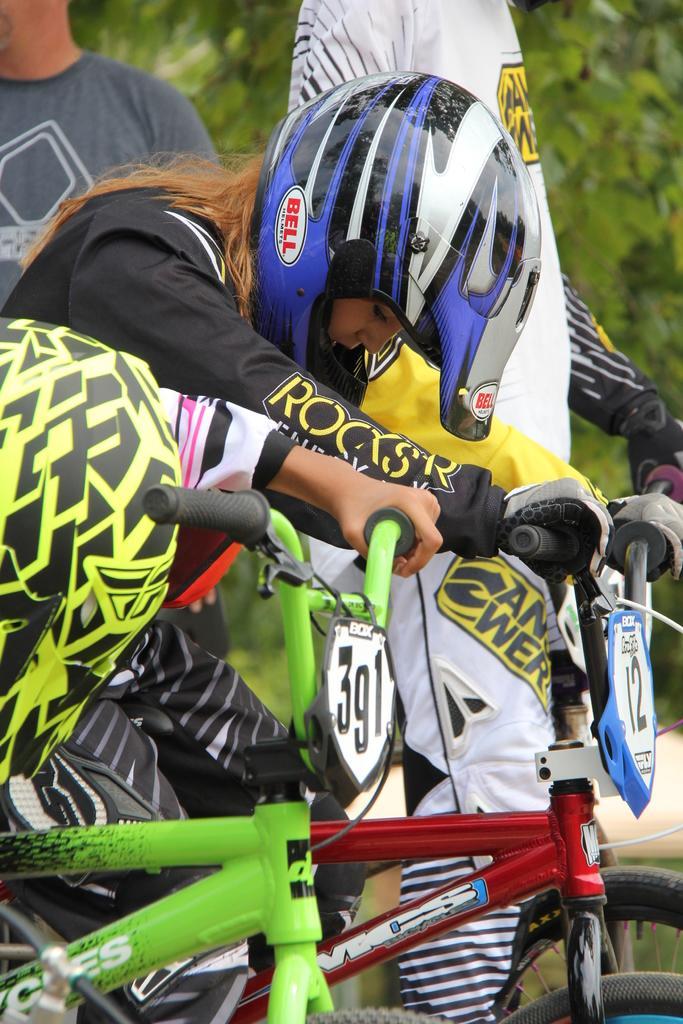Could you give a brief overview of what you see in this image? This picture is of outside. In the foreground we can see a green color bicycle on which a person is sitting, behind him there is a girl sitting on a red color bicycle and wearing helmet. In the background we can see two persons standing and some trees. 